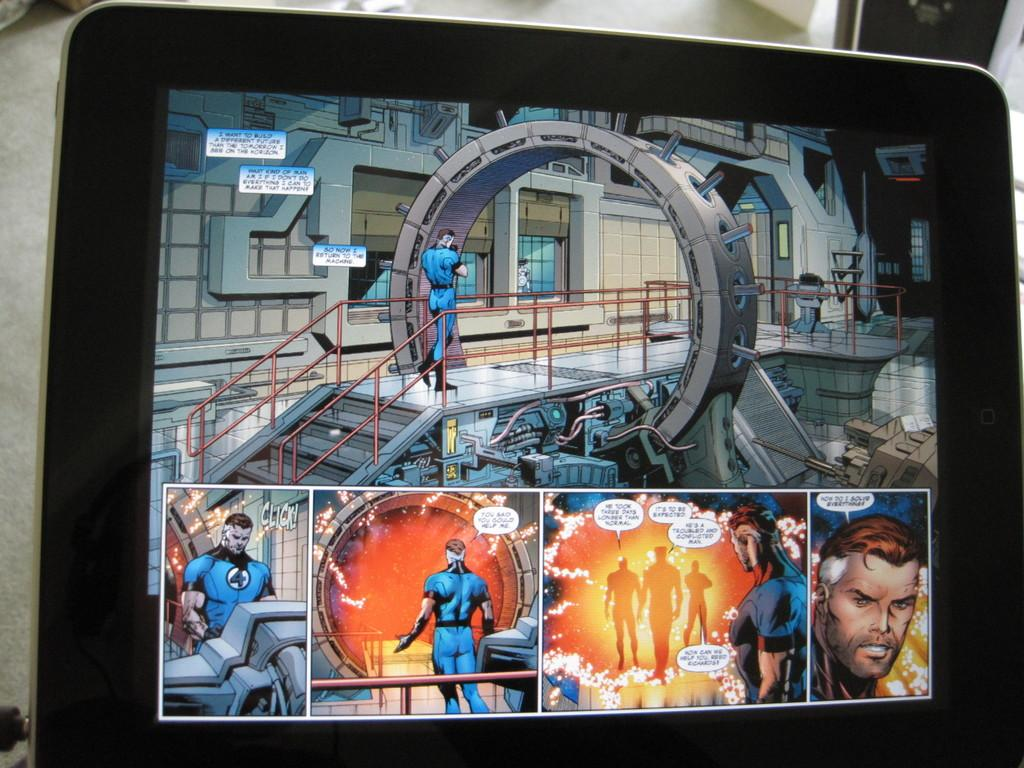What electronic device is present in the image? There is a monitor screen in the image. What can be seen displayed on the monitor screen? There are images visible on the monitor screen. What type of wax is being used to create the lip shape on the crow's beak in the image? There is no wax, lip shape, or crow present in the image. 